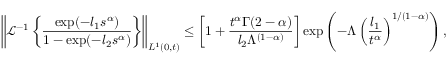<formula> <loc_0><loc_0><loc_500><loc_500>\left \| \mathcal { L } ^ { - 1 } \left \{ \frac { \exp ( - l _ { 1 } s ^ { \alpha } ) } { 1 - \exp ( - l _ { 2 } s ^ { \alpha } ) } \right \} \right \| _ { L ^ { 1 } ( 0 , t ) } \leq \left [ 1 + \frac { t ^ { \alpha } \Gamma ( 2 - \alpha ) } { l _ { 2 } \Lambda ^ { ( 1 - \alpha ) } } \right ] \exp \left ( - \Lambda \left ( \frac { l _ { 1 } } { t ^ { \alpha } } \right ) ^ { 1 / ( 1 - \alpha ) } \right ) ,</formula> 